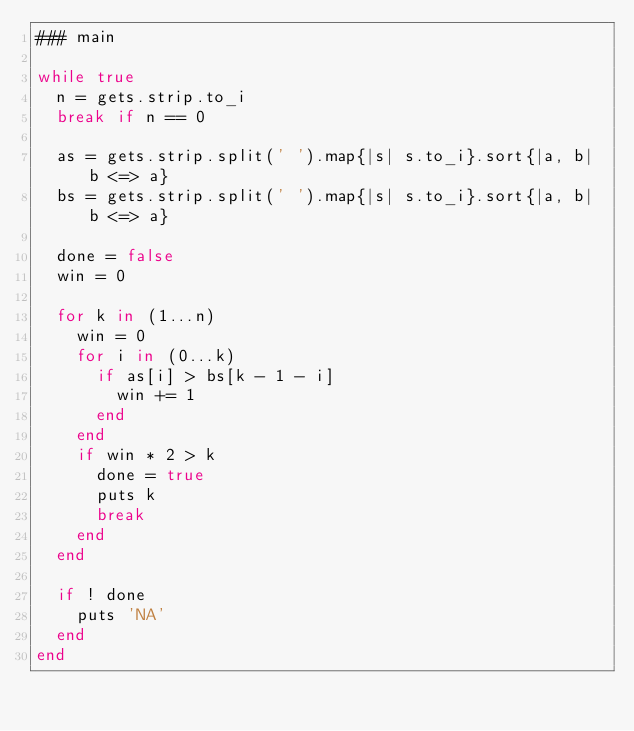Convert code to text. <code><loc_0><loc_0><loc_500><loc_500><_Ruby_>### main

while true
  n = gets.strip.to_i
  break if n == 0

  as = gets.strip.split(' ').map{|s| s.to_i}.sort{|a, b| b <=> a}
  bs = gets.strip.split(' ').map{|s| s.to_i}.sort{|a, b| b <=> a}

  done = false
  win = 0

  for k in (1...n)
    win = 0
    for i in (0...k)
      if as[i] > bs[k - 1 - i]
        win += 1
      end
    end
    if win * 2 > k
      done = true
      puts k
      break
    end
  end

  if ! done
    puts 'NA'
  end
end</code> 